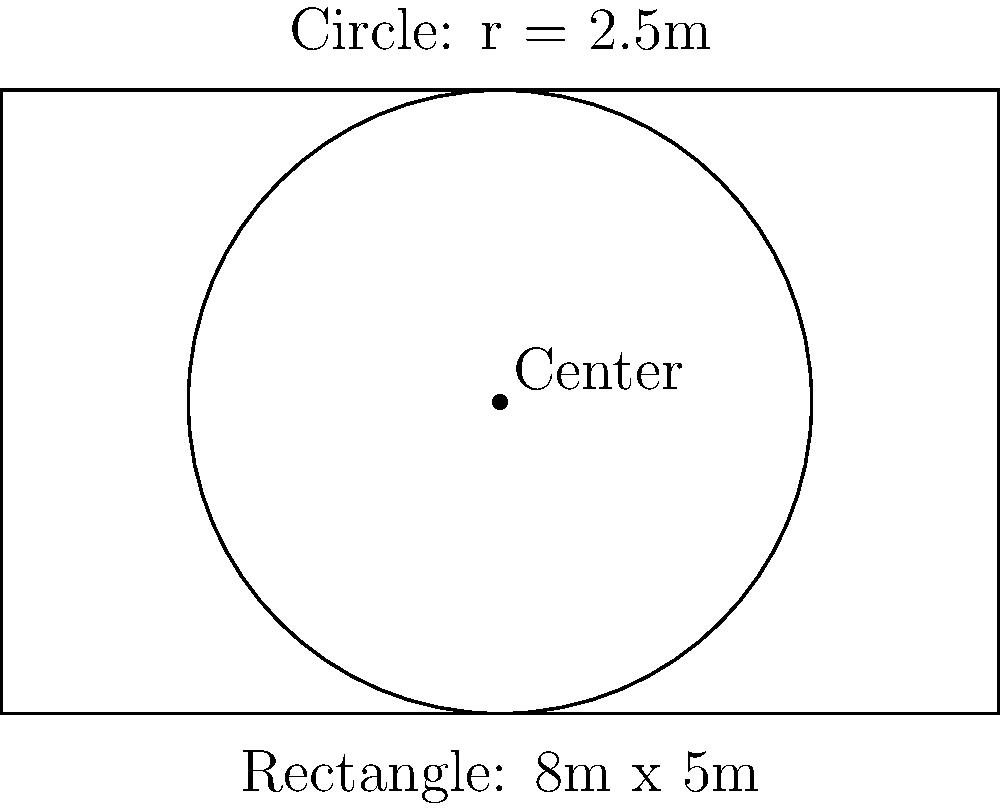A rural community is planning to build a biomass storage facility. They have two design options: a rectangular building (8m x 5m) or a circular silo with a radius of 2.5m. Which design option provides the larger storage area, and by how many square meters? To solve this problem, we need to calculate the areas of both shapes and compare them:

1. Area of the rectangle:
   $A_r = l \times w$
   $A_r = 8 \text{ m} \times 5 \text{ m} = 40 \text{ m}^2$

2. Area of the circle:
   $A_c = \pi r^2$
   $A_c = \pi \times (2.5 \text{ m})^2 = 19.63 \text{ m}^2$

3. Difference in area:
   $\text{Difference} = A_r - A_c$
   $\text{Difference} = 40 \text{ m}^2 - 19.63 \text{ m}^2 = 20.37 \text{ m}^2$

Therefore, the rectangular design provides a larger storage area, with a difference of approximately 20.37 square meters.
Answer: Rectangular design; 20.37 m² 